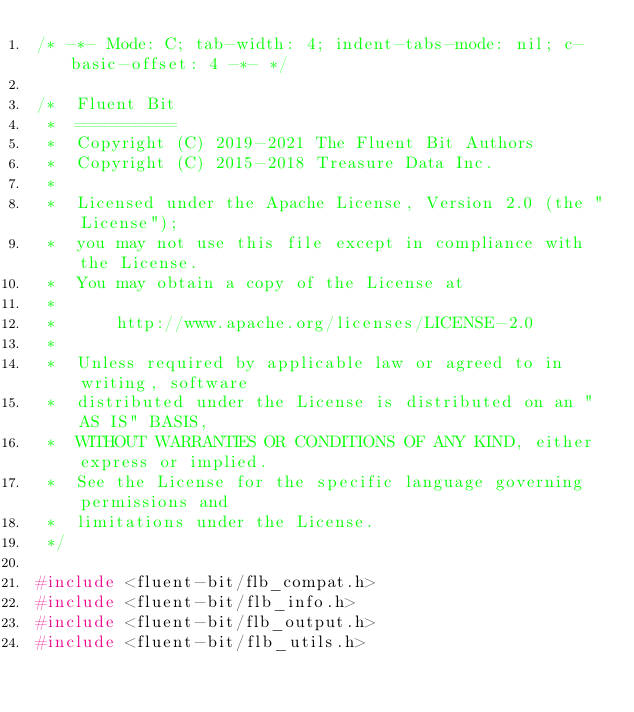Convert code to text. <code><loc_0><loc_0><loc_500><loc_500><_C_>/* -*- Mode: C; tab-width: 4; indent-tabs-mode: nil; c-basic-offset: 4 -*- */

/*  Fluent Bit
 *  ==========
 *  Copyright (C) 2019-2021 The Fluent Bit Authors
 *  Copyright (C) 2015-2018 Treasure Data Inc.
 *
 *  Licensed under the Apache License, Version 2.0 (the "License");
 *  you may not use this file except in compliance with the License.
 *  You may obtain a copy of the License at
 *
 *      http://www.apache.org/licenses/LICENSE-2.0
 *
 *  Unless required by applicable law or agreed to in writing, software
 *  distributed under the License is distributed on an "AS IS" BASIS,
 *  WITHOUT WARRANTIES OR CONDITIONS OF ANY KIND, either express or implied.
 *  See the License for the specific language governing permissions and
 *  limitations under the License.
 */

#include <fluent-bit/flb_compat.h>
#include <fluent-bit/flb_info.h>
#include <fluent-bit/flb_output.h>
#include <fluent-bit/flb_utils.h></code> 